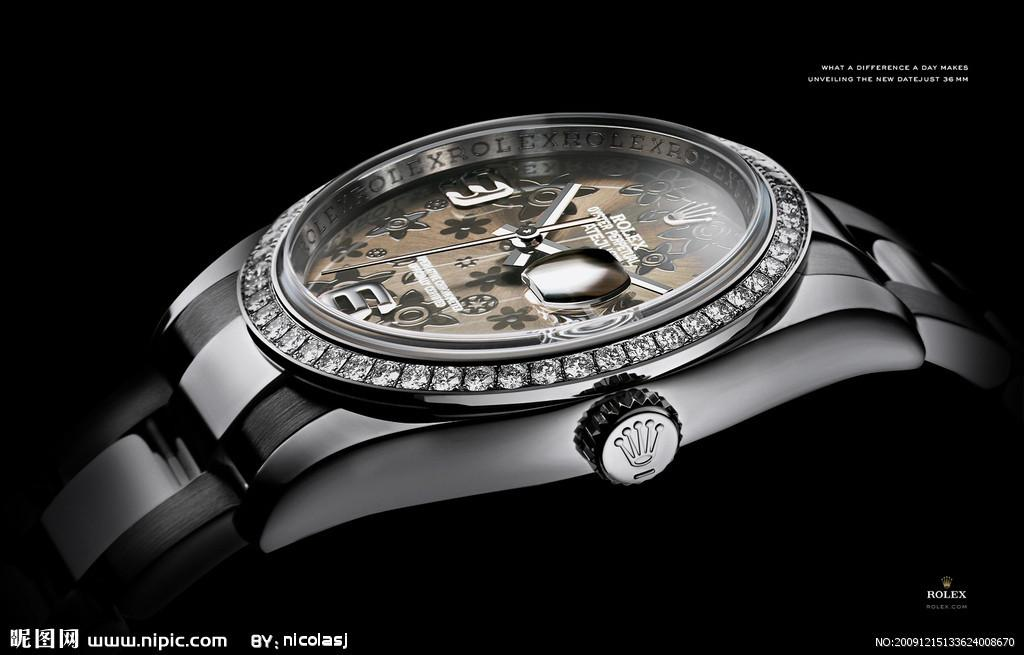<image>
Provide a brief description of the given image. A diamond and silver watch with the digit 3 on the left side.and bottom front. 